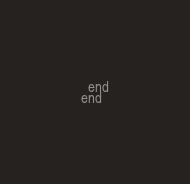<code> <loc_0><loc_0><loc_500><loc_500><_Ruby_>  end
end
</code> 